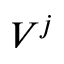Convert formula to latex. <formula><loc_0><loc_0><loc_500><loc_500>V ^ { j }</formula> 